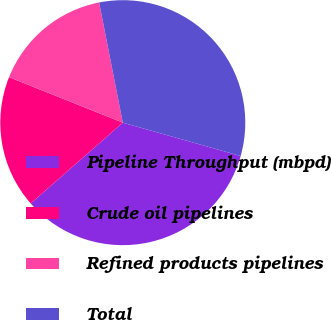Convert chart. <chart><loc_0><loc_0><loc_500><loc_500><pie_chart><fcel>Pipeline Throughput (mbpd)<fcel>Crude oil pipelines<fcel>Refined products pipelines<fcel>Total<nl><fcel>34.15%<fcel>17.52%<fcel>15.85%<fcel>32.48%<nl></chart> 